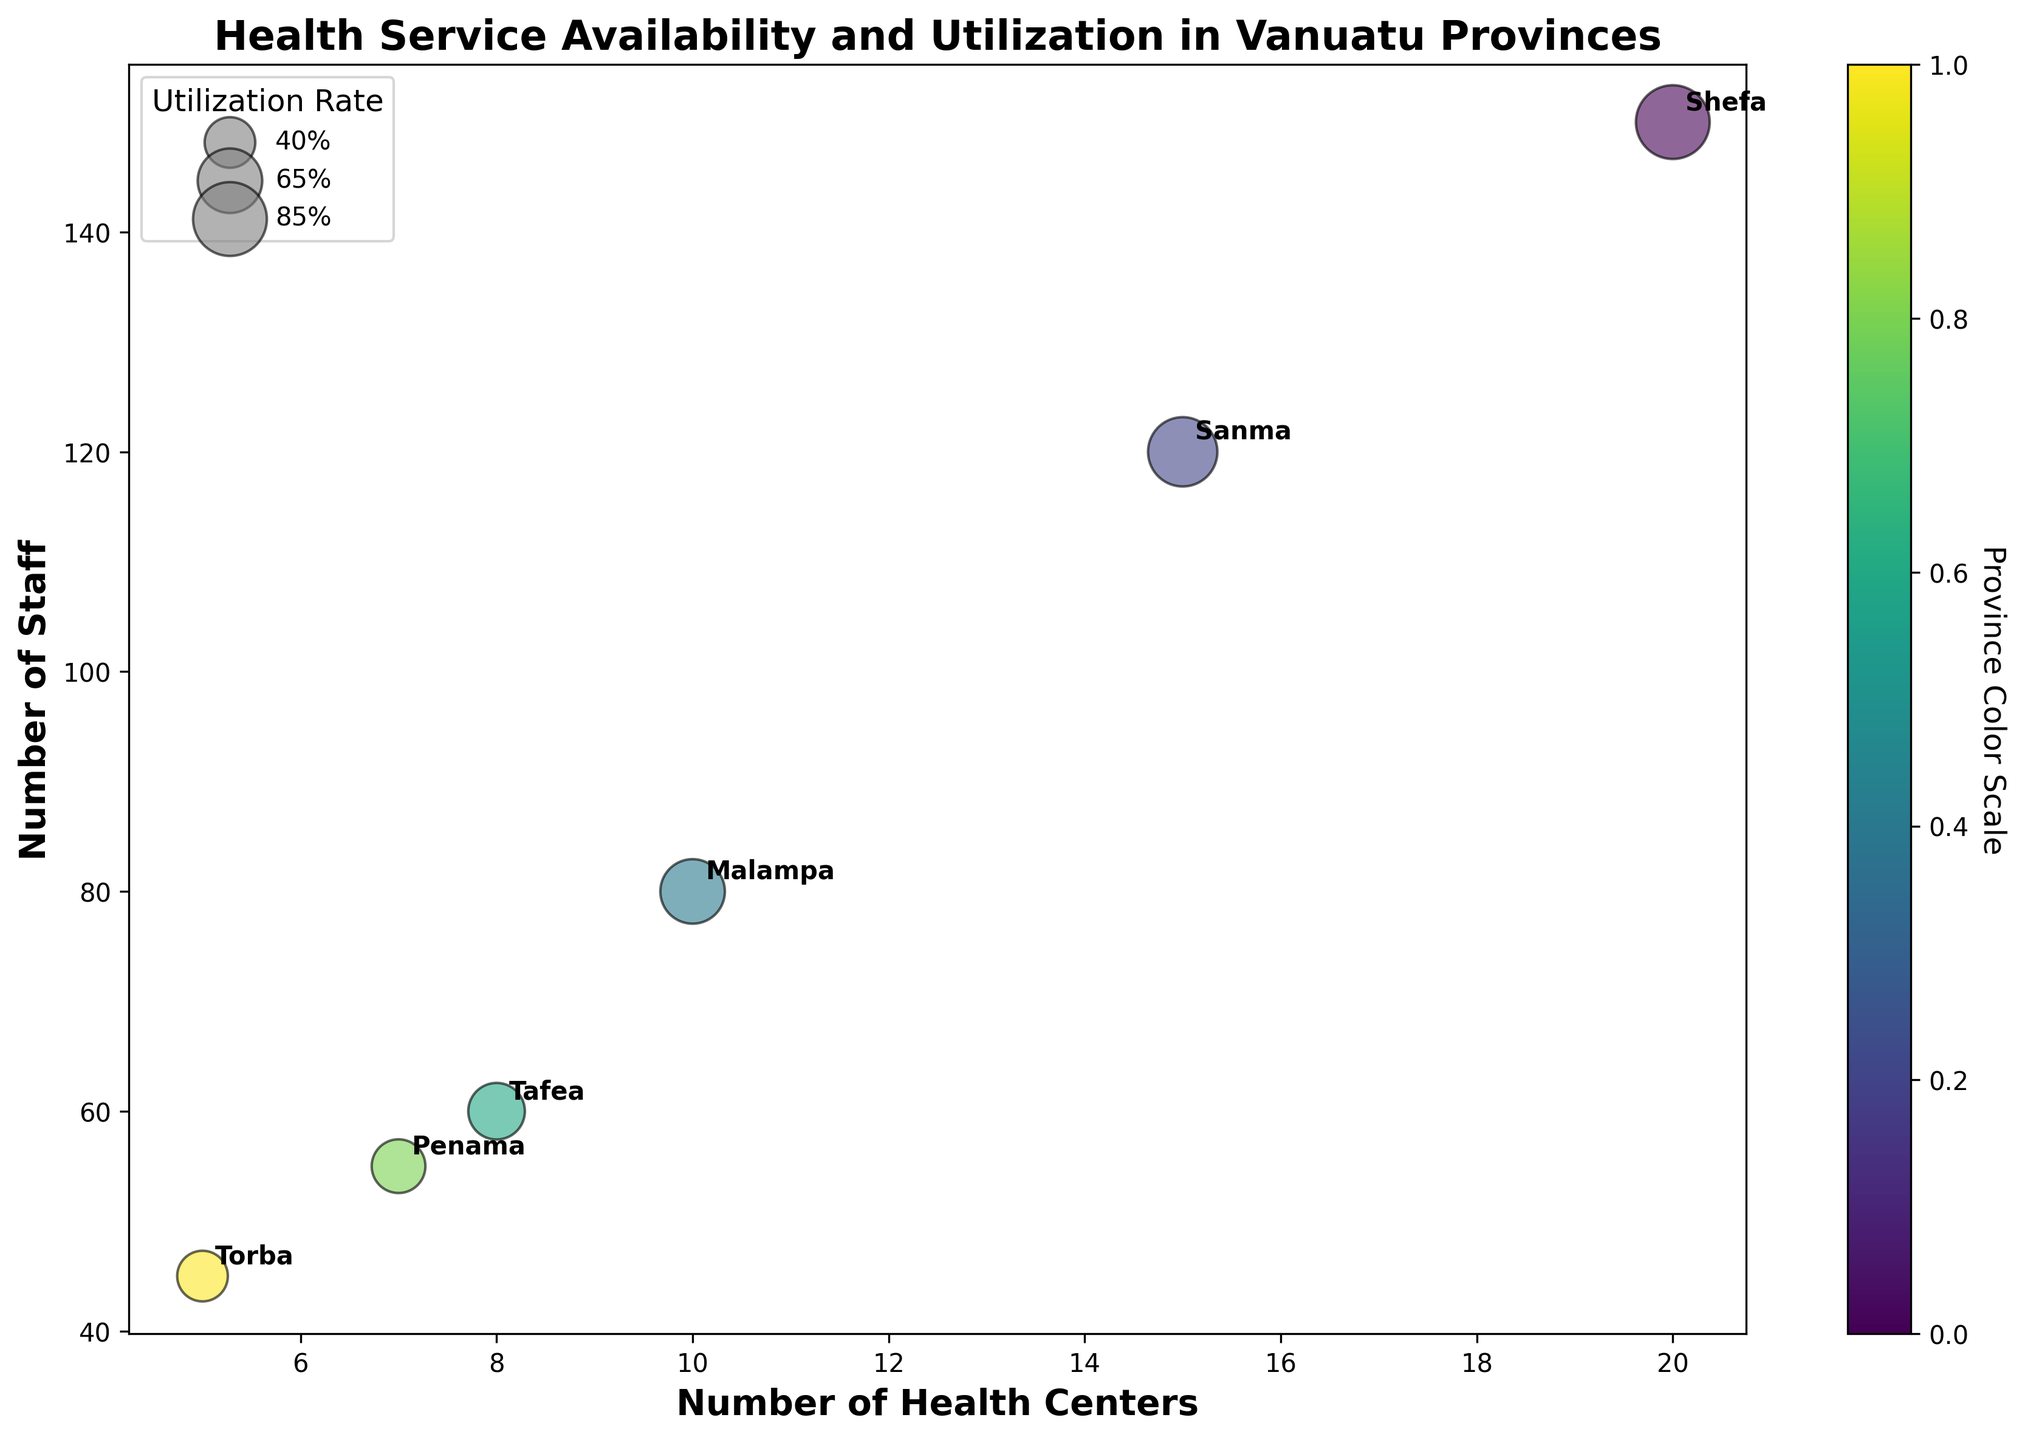what is the title of the chart? The title of the chart is found at the top of the figure, representing the main idea of the visualized data. It states "Health Service Availability and Utilization in Vanuatu Provinces".
Answer: Health Service Availability and Utilization in Vanuatu Provinces How many health centers are there in Shefa? The position of Shefa on the x-axis directly corresponds to the number of health centers. The province name annotation near this position confirms the data point.
Answer: 20 Which province has the highest number of staff? To determine this, compare the y-positions of each data point labeled with the province names. The higher the position on the y-axis, the greater the number of staff. Shefa has the highest staff number at the topmost position.
Answer: Shefa Which province has the smallest utilization rate? The size of the bubbles represents the utilization rate. Torba has the smallest bubble size, indicating the lowest utilization rate.
Answer: Torba What is the combined number of health centers in Sanma and Malampa? Sum the number of health centers in Sanma and Malampa, found by locating both provinces on the x-axis: 15 (Sanma) + 10 (Malampa) = 25.
Answer: 25 Which province has a health issue related to Malnutrition? Look for the common health issues annotated near each province label. Penama has "Malnutrition:20%" labeled as its common health issue.
Answer: Penama Is the number of health centers in Malampa greater than in Torba? Compare the x-axis positions of Malampa and Torba. Malampa's x position (10 health centers) is greater than Torba's x position (5 health centers).
Answer: Yes How many staff members are there in Tafea compared to Penama? Subtract the staff number in Penama (55) from Tafea's staff number (60): 60 - 55 = 5.
Answer: 5 What is the sum of utilization rates for Shefa and Sanma? Add the utilization rates visible from the bubble sizes or legend: 85 (Shefa) + 75 (Sanma) = 160.
Answer: 160 Which province has the highest utilization rate? Check the legend and bubble sizes to identify the largest bubble which corresponds to the highest utilization rate. Shefa has the largest bubble indicating the highest utilization rate.
Answer: Shefa 